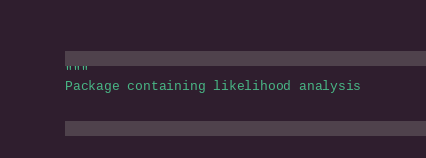<code> <loc_0><loc_0><loc_500><loc_500><_Python_>"""
Package containing likelihood analysis
</code> 